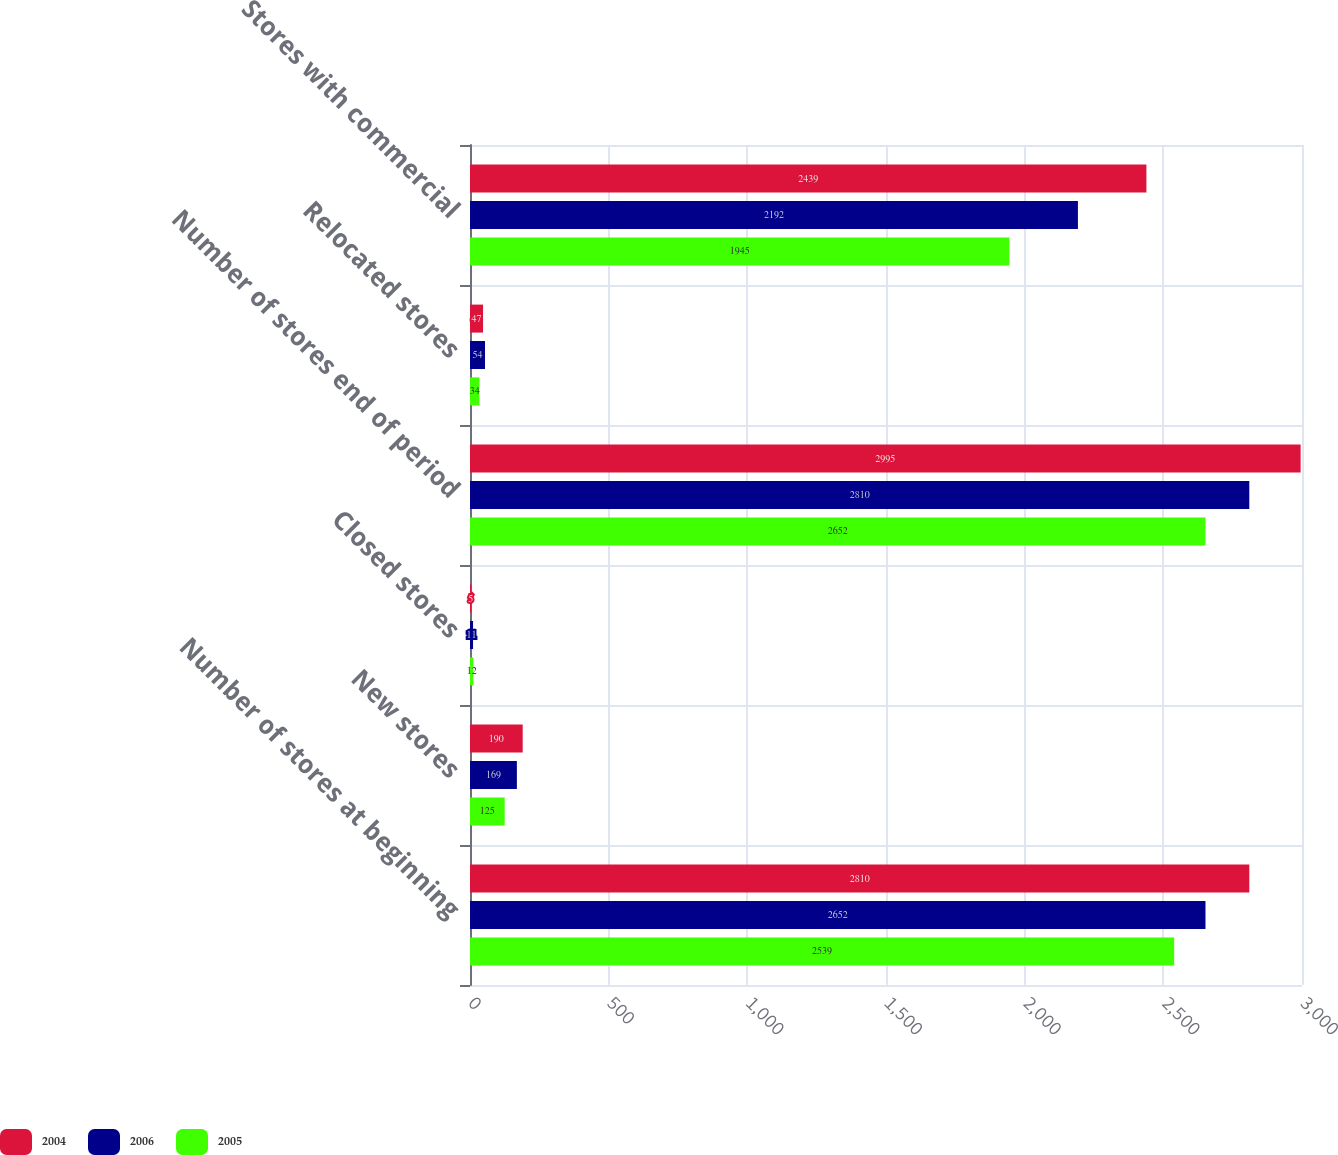<chart> <loc_0><loc_0><loc_500><loc_500><stacked_bar_chart><ecel><fcel>Number of stores at beginning<fcel>New stores<fcel>Closed stores<fcel>Number of stores end of period<fcel>Relocated stores<fcel>Stores with commercial<nl><fcel>2004<fcel>2810<fcel>190<fcel>5<fcel>2995<fcel>47<fcel>2439<nl><fcel>2006<fcel>2652<fcel>169<fcel>11<fcel>2810<fcel>54<fcel>2192<nl><fcel>2005<fcel>2539<fcel>125<fcel>12<fcel>2652<fcel>34<fcel>1945<nl></chart> 